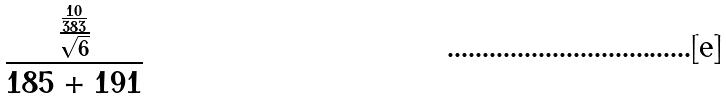Convert formula to latex. <formula><loc_0><loc_0><loc_500><loc_500>\frac { \frac { \frac { 1 0 } { 3 8 3 } } { \sqrt { 6 } } } { 1 8 5 + 1 9 1 }</formula> 